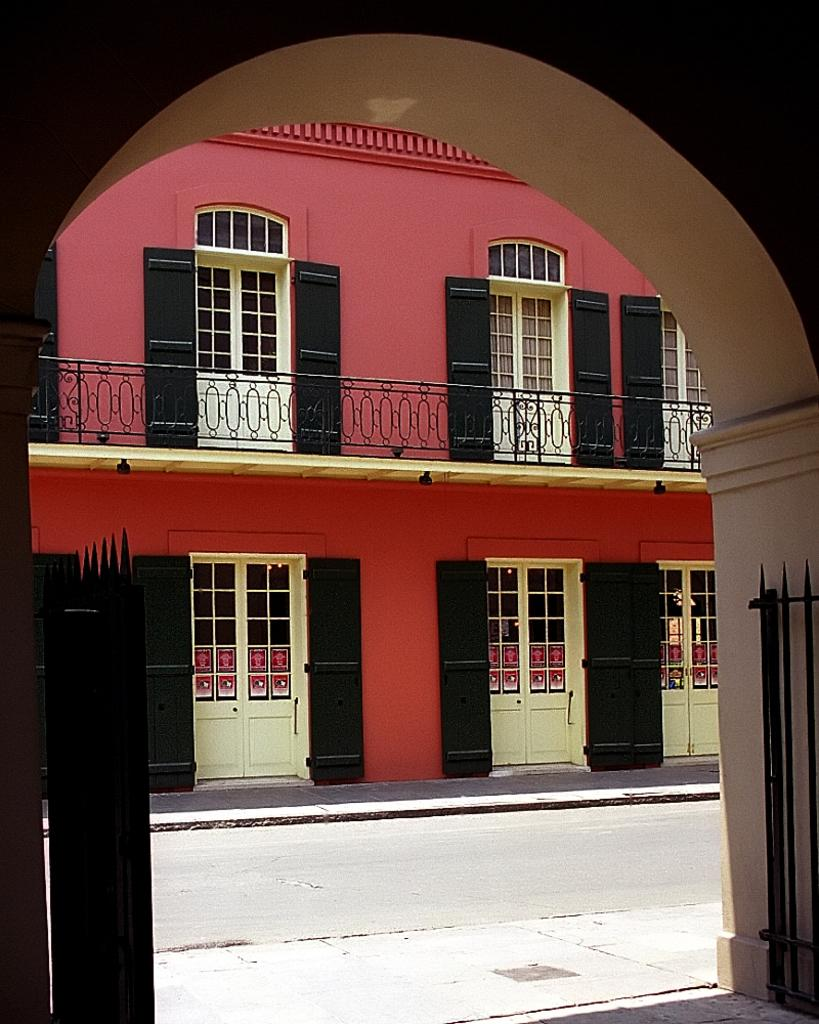What type of structure can be seen in the image? There is a gate and an arch in the image. What else is visible in the image besides the gate and arch? There is a road and a building with doors in the image. What type of loaf is being used to hold the gate open in the image? There is no loaf present in the image, and the gate is not being held open. 